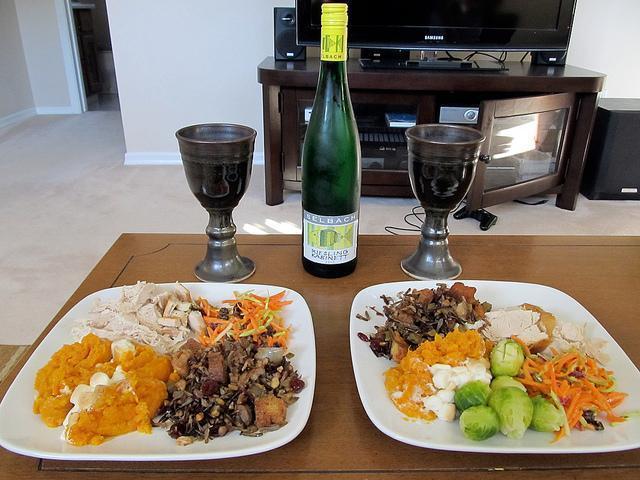Where in the house are they likely planning to dine?
Select the accurate response from the four choices given to answer the question.
Options: Living room, porch, kitchen, dining room. Living room. 